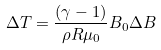Convert formula to latex. <formula><loc_0><loc_0><loc_500><loc_500>\Delta T = \frac { ( \gamma - 1 ) } { \rho R \mu _ { 0 } } B _ { 0 } \Delta B</formula> 